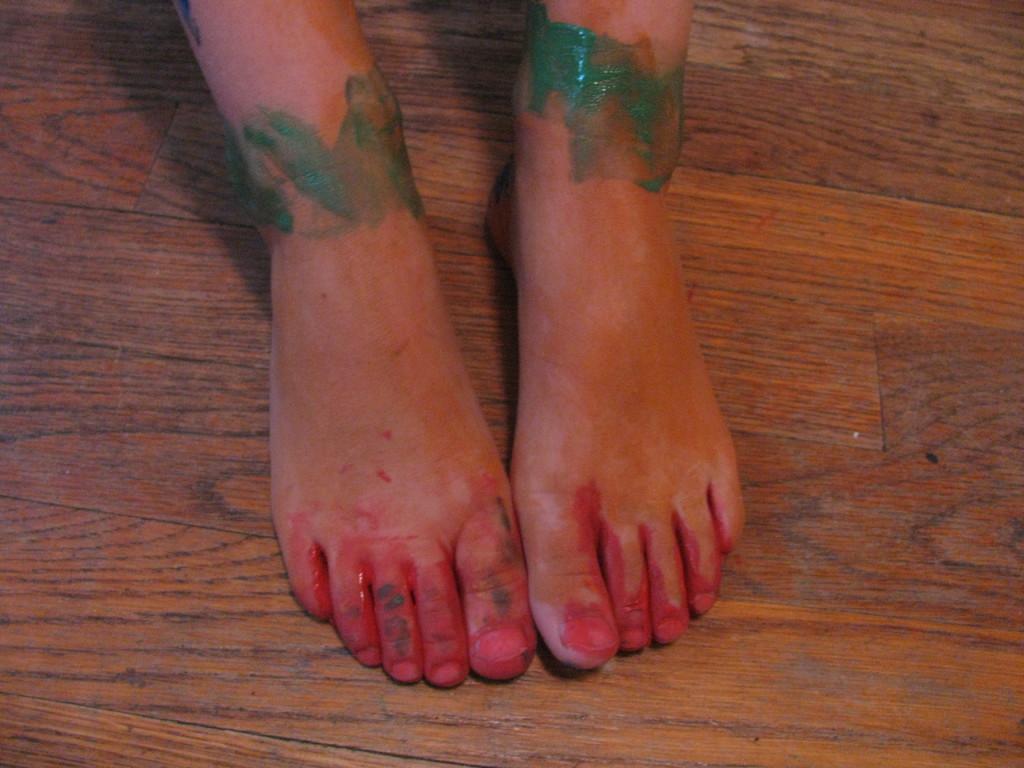Describe this image in one or two sentences. In this image, we can see the legs of a person on the wooden surface. 